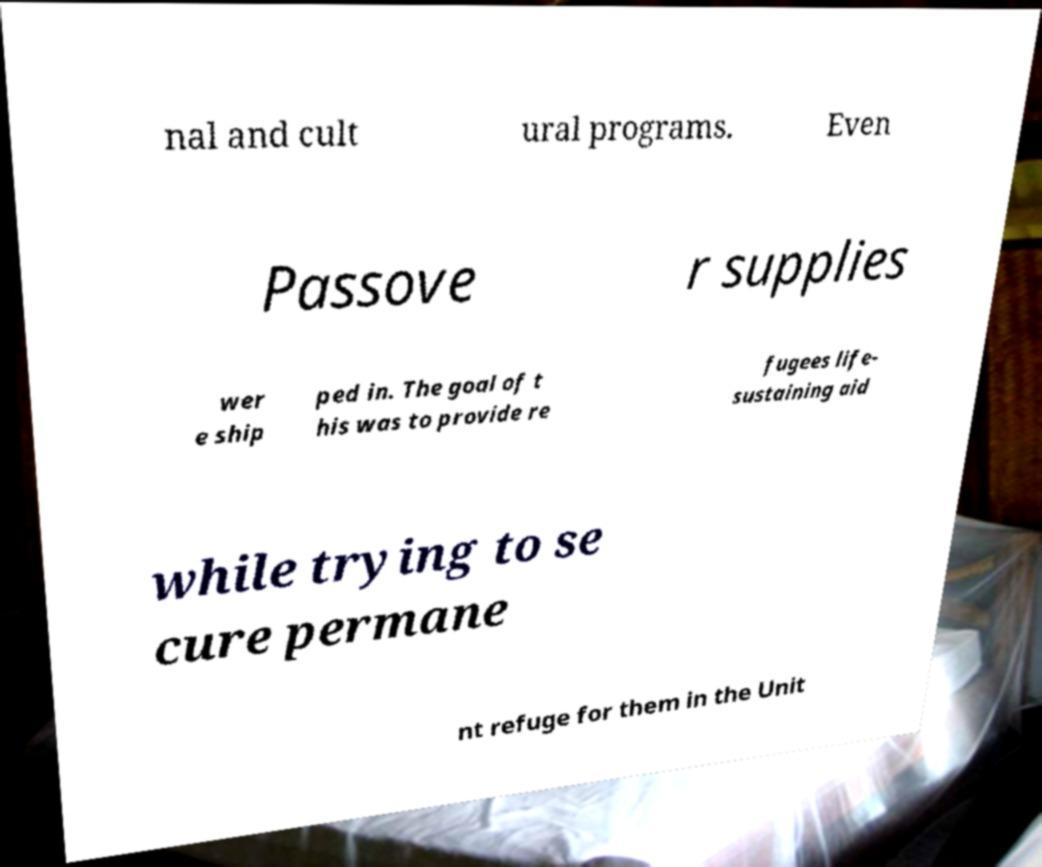Can you read and provide the text displayed in the image?This photo seems to have some interesting text. Can you extract and type it out for me? nal and cult ural programs. Even Passove r supplies wer e ship ped in. The goal of t his was to provide re fugees life- sustaining aid while trying to se cure permane nt refuge for them in the Unit 